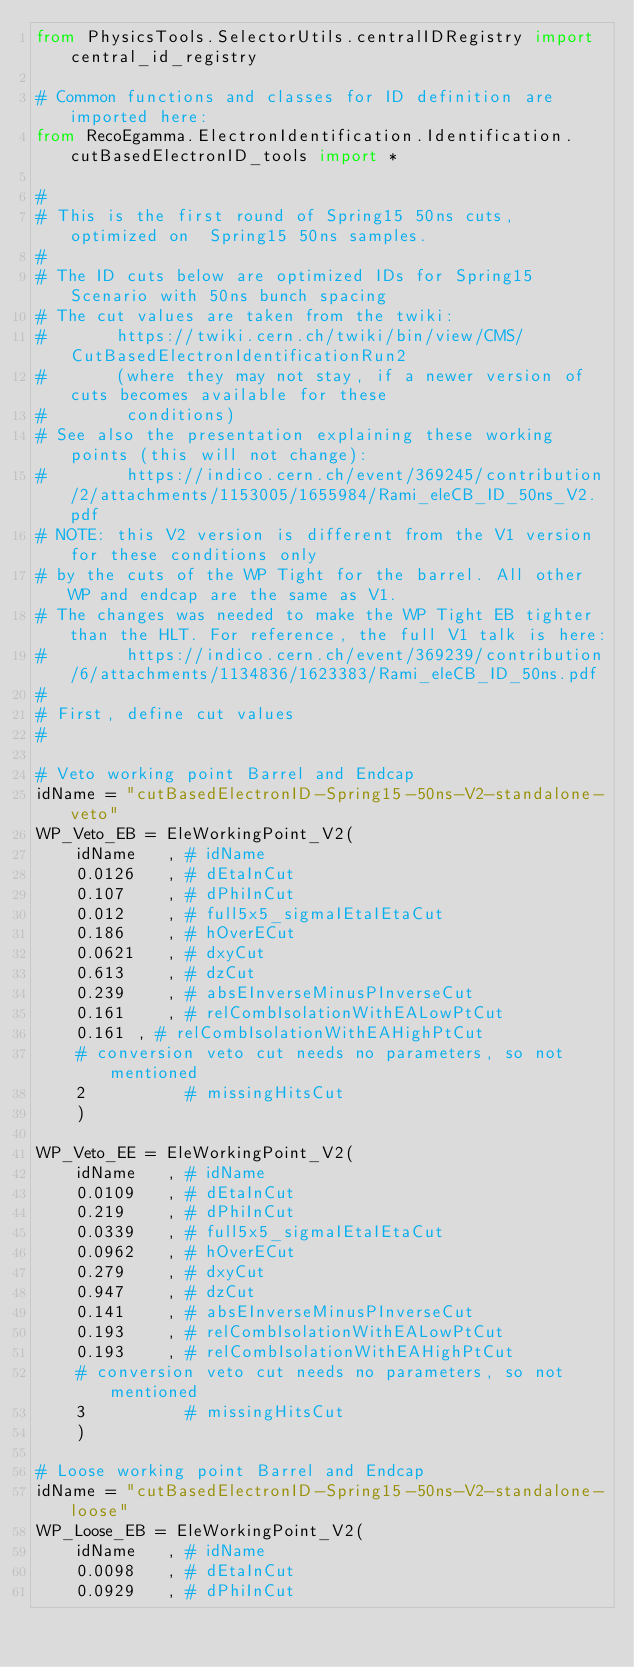Convert code to text. <code><loc_0><loc_0><loc_500><loc_500><_Python_>from PhysicsTools.SelectorUtils.centralIDRegistry import central_id_registry

# Common functions and classes for ID definition are imported here:
from RecoEgamma.ElectronIdentification.Identification.cutBasedElectronID_tools import *

#
# This is the first round of Spring15 50ns cuts, optimized on  Spring15 50ns samples. 
#
# The ID cuts below are optimized IDs for Spring15 Scenario with 50ns bunch spacing
# The cut values are taken from the twiki:
#       https://twiki.cern.ch/twiki/bin/view/CMS/CutBasedElectronIdentificationRun2
#       (where they may not stay, if a newer version of cuts becomes available for these
#        conditions)
# See also the presentation explaining these working points (this will not change):
#        https://indico.cern.ch/event/369245/contribution/2/attachments/1153005/1655984/Rami_eleCB_ID_50ns_V2.pdf
# NOTE: this V2 version is different from the V1 version for these conditions only
# by the cuts of the WP Tight for the barrel. All other WP and endcap are the same as V1.
# The changes was needed to make the WP Tight EB tighter than the HLT. For reference, the full V1 talk is here:
#        https://indico.cern.ch/event/369239/contribution/6/attachments/1134836/1623383/Rami_eleCB_ID_50ns.pdf
#
# First, define cut values
#

# Veto working point Barrel and Endcap
idName = "cutBasedElectronID-Spring15-50ns-V2-standalone-veto"
WP_Veto_EB = EleWorkingPoint_V2(
    idName   , # idName
    0.0126   , # dEtaInCut
    0.107    , # dPhiInCut
    0.012    , # full5x5_sigmaIEtaIEtaCut
    0.186    , # hOverECut
    0.0621   , # dxyCut
    0.613    , # dzCut
    0.239    , # absEInverseMinusPInverseCut
    0.161    , # relCombIsolationWithEALowPtCut
    0.161 , # relCombIsolationWithEAHighPtCut
    # conversion veto cut needs no parameters, so not mentioned
    2          # missingHitsCut
    )

WP_Veto_EE = EleWorkingPoint_V2(
    idName   , # idName
    0.0109   , # dEtaInCut
    0.219    , # dPhiInCut
    0.0339   , # full5x5_sigmaIEtaIEtaCut
    0.0962   , # hOverECut
    0.279    , # dxyCut
    0.947    , # dzCut
    0.141    , # absEInverseMinusPInverseCut
    0.193    , # relCombIsolationWithEALowPtCut
    0.193    , # relCombIsolationWithEAHighPtCut
    # conversion veto cut needs no parameters, so not mentioned
    3          # missingHitsCut
    )

# Loose working point Barrel and Endcap
idName = "cutBasedElectronID-Spring15-50ns-V2-standalone-loose"
WP_Loose_EB = EleWorkingPoint_V2(
    idName   , # idName
    0.0098   , # dEtaInCut
    0.0929   , # dPhiInCut</code> 